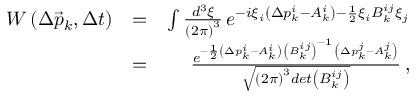<formula> <loc_0><loc_0><loc_500><loc_500>\begin{array} { r l r } { W \left ( \Delta \vec { p } _ { k } , \Delta t \right ) } & { = } & { \int \frac { d ^ { 3 } \xi } { \left ( 2 \pi \right ) ^ { 3 } } \, e ^ { - i \xi _ { i } \left ( \Delta p _ { k } ^ { i } - A _ { k } ^ { i } \right ) - \frac { 1 } { 2 } \xi _ { i } B _ { k } ^ { i j } \xi _ { j } } } \\ & { = } & { \frac { e ^ { - \frac { 1 } { 2 } \left ( \Delta p _ { k } ^ { i } - A _ { k } ^ { i } \right ) \, \left ( B _ { k } ^ { i j } \right ) ^ { - 1 } \, \left ( \Delta p _ { k } ^ { j } - A _ { k } ^ { j } \right ) } } { \sqrt { \left ( 2 \pi \right ) ^ { 3 } d e t \left ( B _ { k } ^ { i j } \right ) } } \, , } \end{array}</formula> 